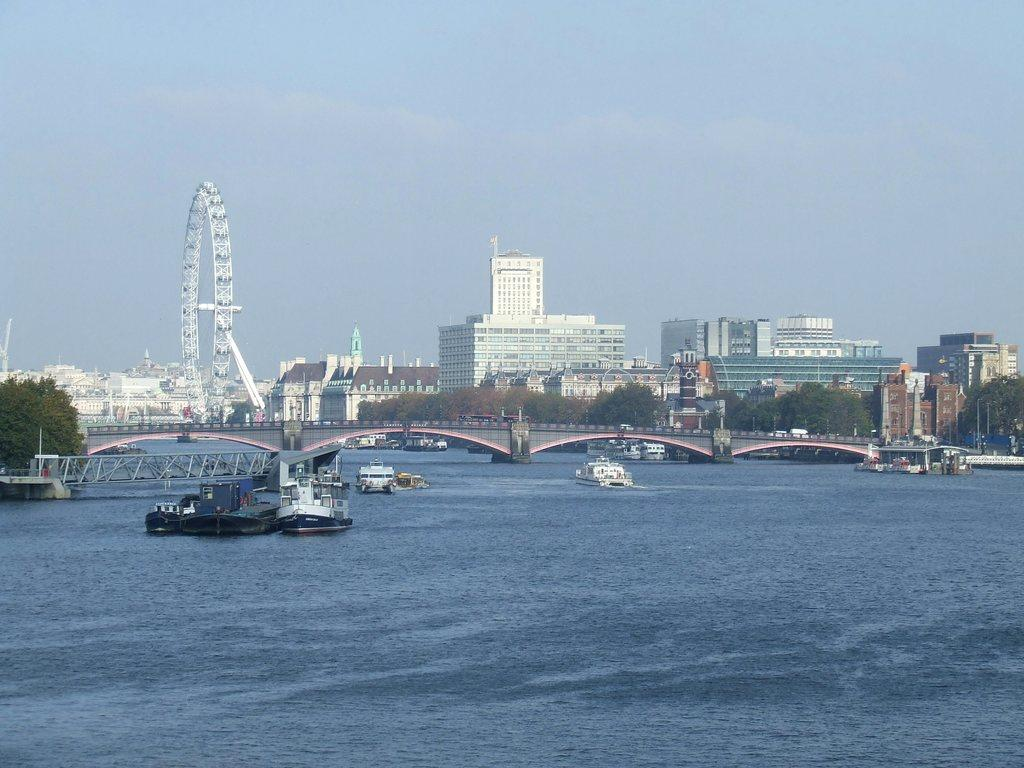What is floating on the water in the image? There are boats floating on the water in the image. What can be seen in the middle of the image? There is a bridge and buildings in the middle of the image. What is visible in the background of the image? The sky is visible in the background of the image. How does the coach control the boats in the image? There is no coach present in the image, and the boats are floating on the water without any visible control. What type of good-bye is being exchanged between the buildings in the image? There is no indication of any good-bye being exchanged in the image; the buildings are simply present in the scene. 